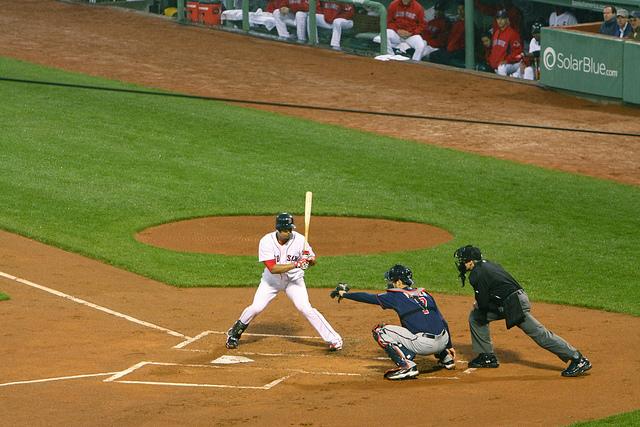What sport are they playing?
Quick response, please. Baseball. What color shirt is the man wearing under his Jersey?
Short answer required. Red. What is the throwing handedness of the catcher?
Quick response, please. Right. What team is the batter from?
Answer briefly. Red sox. Where is the batter looking?
Answer briefly. At catcher. What is the player doing?
Keep it brief. Batting. What color is the bat?
Keep it brief. White. What colors are the man's shoes?
Concise answer only. Black. How many players are on the field?
Keep it brief. 3. What sport is taking place?
Give a very brief answer. Baseball. What team is catching?
Give a very brief answer. Mets. Is the batter right-handed?
Write a very short answer. No. Is the batter swinging at this pitch?
Short answer required. No. 